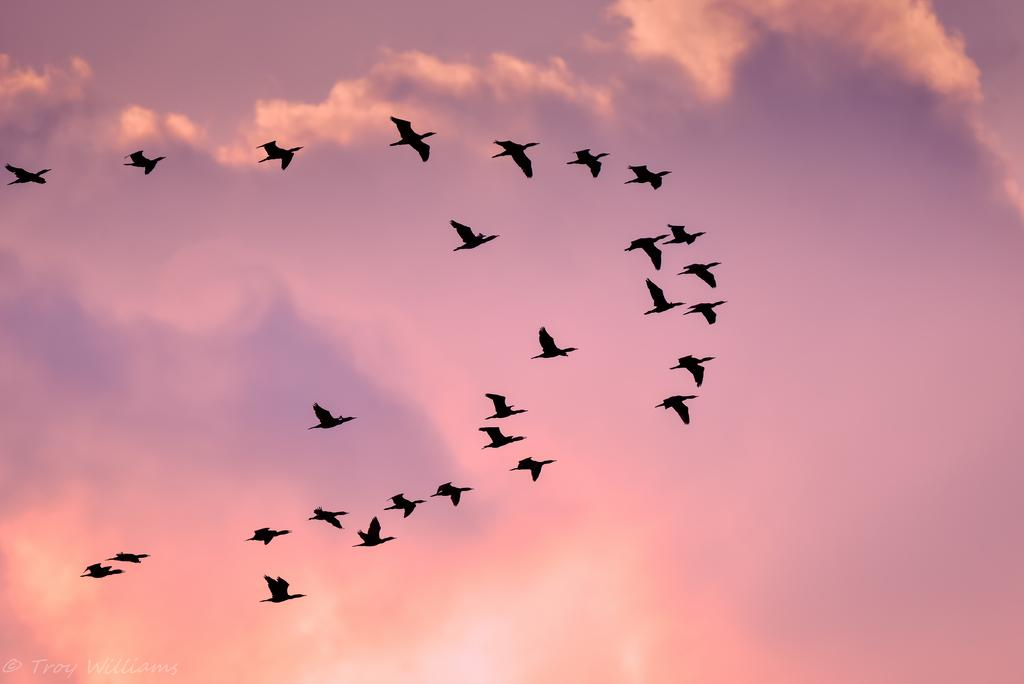What type of animals can be seen in the image? Birds can be seen in the image. What are the birds doing in the image? The birds are flying in the sky. What is the effect of the school on the birds in the image? There is no school present in the image, so it is not possible to determine any effect on the birds. 